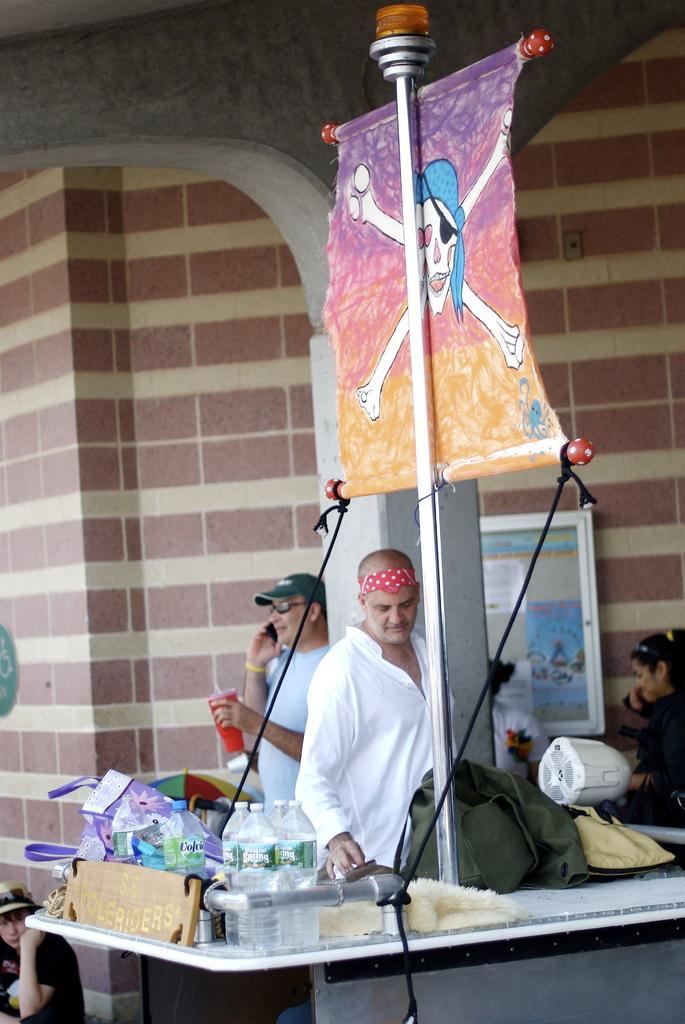Please provide a concise description of this image. In this image there is a table. On the table there are bottles, a board and bags. Behind the table there are a few people standing. Near to the table there is a pole. There is a banner to the pole. In the background there is a wall. In the bottom left there is a person sitting on the ground. 